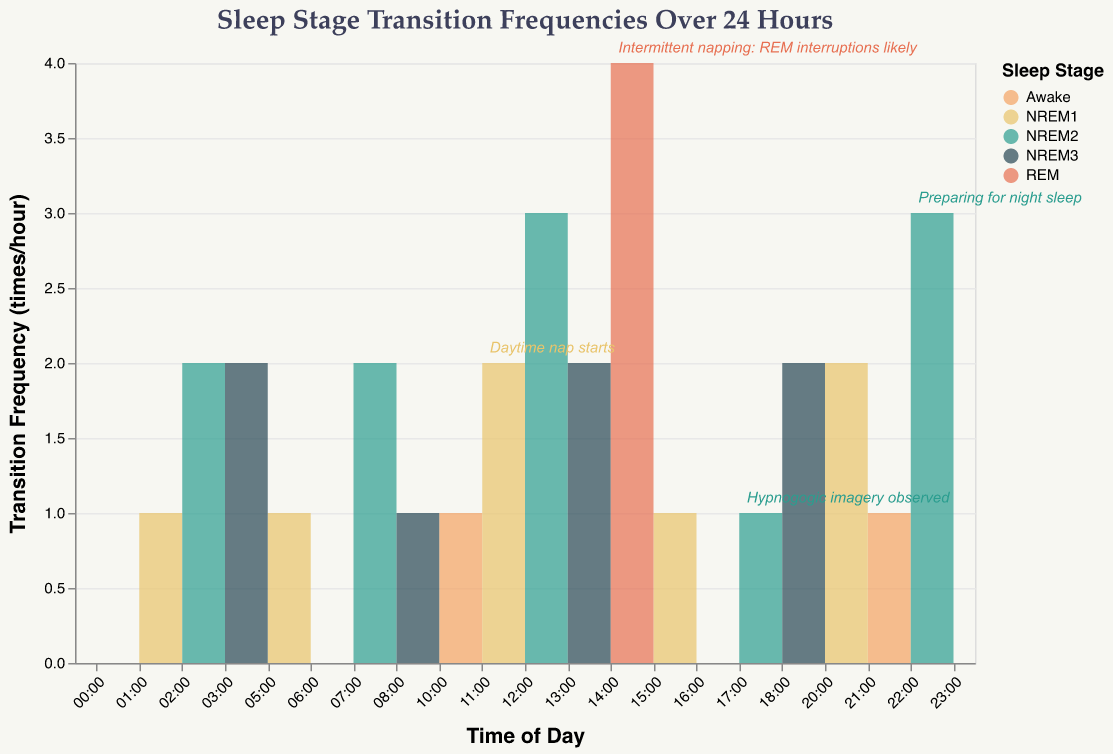What is the title of the chart? The title of the chart is found at the top of the figure, describing the main subject of the visualized data.
Answer: Sleep Stage Transition Frequencies Over 24 Hours What colors correspond to the different sleep stages? The colors are depicted in the legend on the right side of the chart, each indicating a specific sleep stage. Awake is orange, NREM1 is yellow, NREM2 is green, NREM3 is dark blue, and REM is red.
Answer: Orange for Awake, Yellow for NREM1, Green for NREM2, Dark blue for NREM3, Red for REM How many hours in total have a transition frequency of 2 times per hour? Counting all the points on the y-axis with a value of 2 across the x-axis timeline reveals the number of occurrences.
Answer: 7 hours How does the transition frequency at 14:00 compare to that at 10:00? Observing the height of the area chart at 14:00 and comparing it to 10:00 shows how many transitions occur at each hour. 14:00 has a transition frequency of 4 while 10:00 has 1, indicating 14:00 has a higher frequency.
Answer: 14:00 has a higher transition frequency When do REM interruptions likely occur according to the notes? Look for the notes marked on the figure and find the one indicating "Intermittent napping: REM interruptions likely."
Answer: 14:00 Which stage shows the highest transition frequency over the 24-hour period? By identifying the color corresponding to the highest peak on the y-axis, we see which sleep stage has the highest transition frequency. The red color for REM shows the highest peak at 14:00.
Answer: REM How many stages show no transitions at certain hours? Count the instances where the y-axis value is 0 on the area chart to determine the number of stages with no transitions.
Answer: 3 stages (Awake at 00:00, Awake at 06:00, and Awake at 16:00) What is the average transition frequency between midnight (00:00) and noon (12:00)? Sum up the transition frequencies at each hour from 00:00 to 12:00 and divide by the total number of hours (13 hours). (0+1+2+2+1+0+2+1+1+2+3) = 15, divided by 12 hours gives an average of 1.25
Answer: 1.25 Explain the transition frequency pattern observed during the daytime nap starting at 11:00. Look at the transition frequencies from 11:00 to around 15:00. For the daytime nap, begin at 2 times per hour at 11:00, increase to 3 times at 12:00, reach a peak at 4 times during REM at 14:00, and then reduce significantly to 1 time per hour at 15:00, showing a peak then a decline.
Answer: Starts at 2, peaks at 4, decreases to 1 